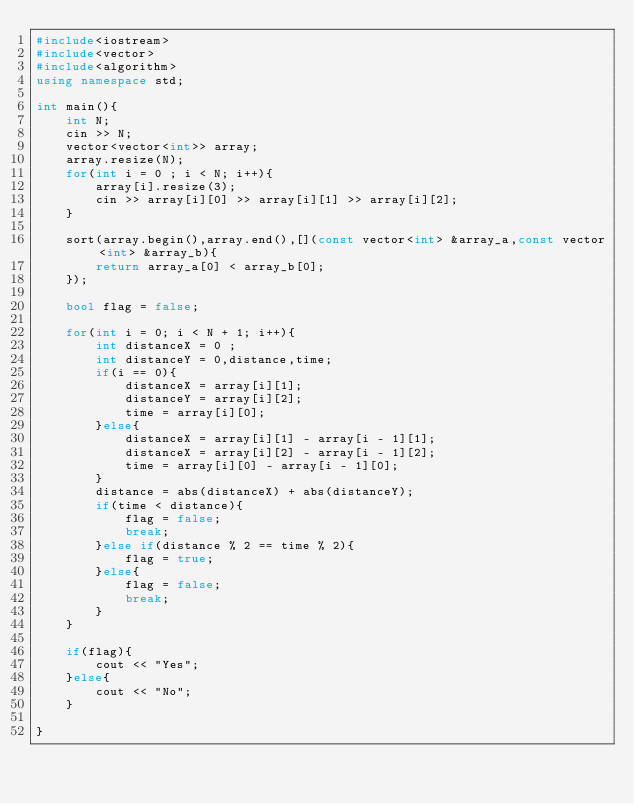<code> <loc_0><loc_0><loc_500><loc_500><_C++_>#include<iostream>
#include<vector>
#include<algorithm>
using namespace std;

int main(){
    int N;
    cin >> N;
    vector<vector<int>> array;
    array.resize(N);
    for(int i = 0 ; i < N; i++){
        array[i].resize(3);
        cin >> array[i][0] >> array[i][1] >> array[i][2];
    }
    
    sort(array.begin(),array.end(),[](const vector<int> &array_a,const vector<int> &array_b){
        return array_a[0] < array_b[0];
    });

    bool flag = false;

    for(int i = 0; i < N + 1; i++){
        int distanceX = 0 ;
        int distanceY = 0,distance,time;
        if(i == 0){
            distanceX = array[i][1];
            distanceY = array[i][2];
            time = array[i][0];
        }else{
            distanceX = array[i][1] - array[i - 1][1];
            distanceX = array[i][2] - array[i - 1][2];
            time = array[i][0] - array[i - 1][0];
        }
        distance = abs(distanceX) + abs(distanceY);
        if(time < distance){
            flag = false;
            break;
        }else if(distance % 2 == time % 2){
            flag = true;
        }else{
            flag = false;
            break;
        }
    }

    if(flag){
        cout << "Yes";
    }else{
        cout << "No";
    }
    
}</code> 